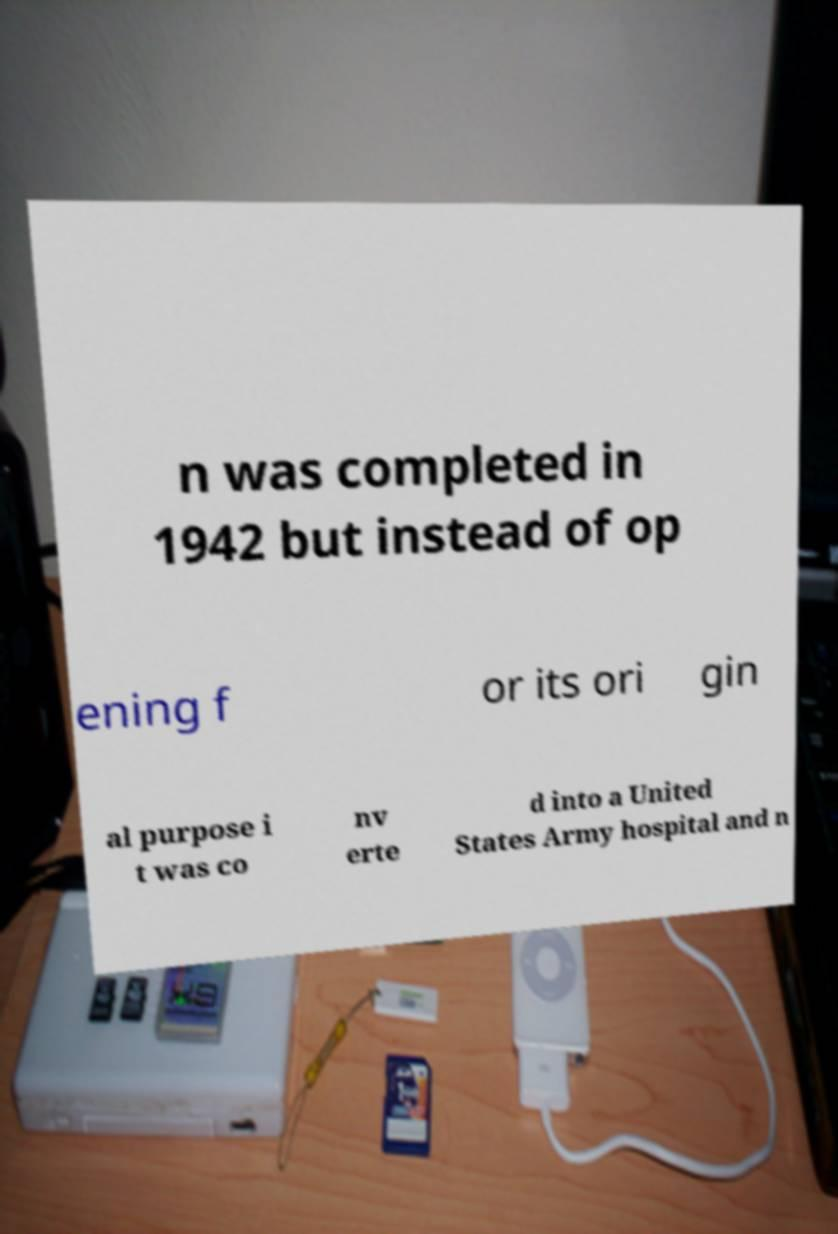Please read and relay the text visible in this image. What does it say? n was completed in 1942 but instead of op ening f or its ori gin al purpose i t was co nv erte d into a United States Army hospital and n 